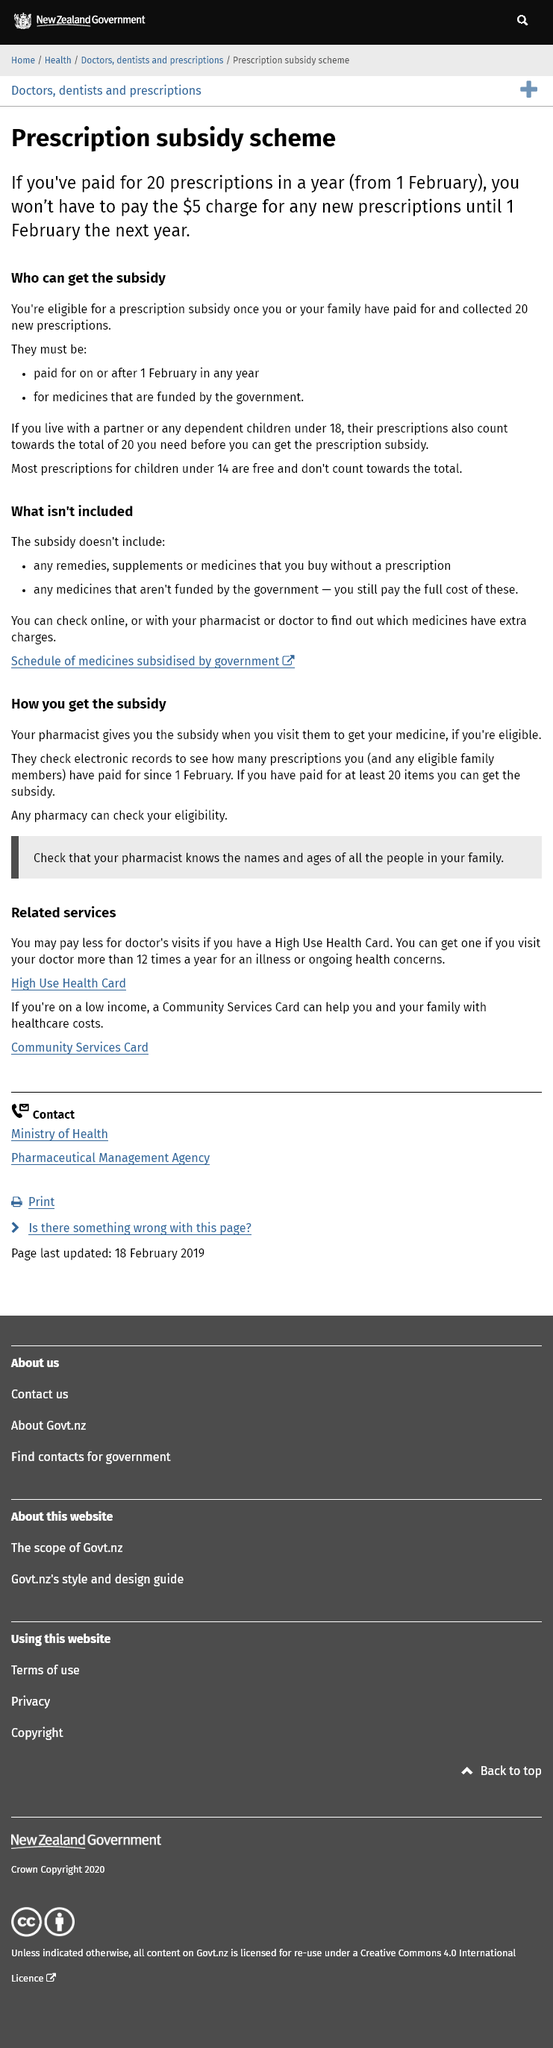List a handful of essential elements in this visual. If you live with a partner and their prescriptions count towards the subsidy, then their prescriptions count towards the subsidy. Most prescriptions for children under the age of 14 are free. The subsidy does not cover remedies, supplements, medicines purchased without a prescription, or medications that are not funded by the government. 